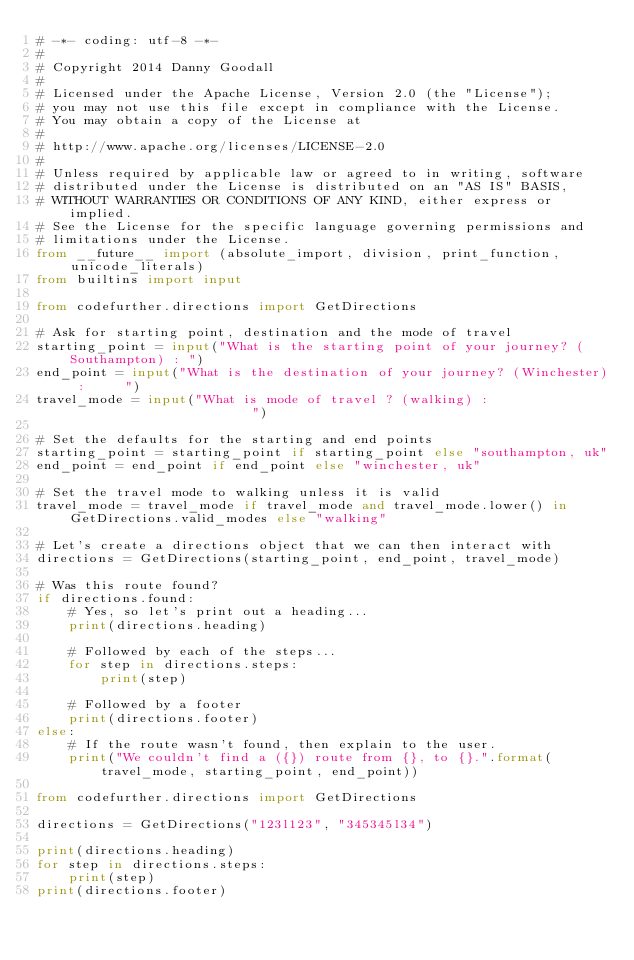Convert code to text. <code><loc_0><loc_0><loc_500><loc_500><_Python_># -*- coding: utf-8 -*-
#
# Copyright 2014 Danny Goodall
#
# Licensed under the Apache License, Version 2.0 (the "License");
# you may not use this file except in compliance with the License.
# You may obtain a copy of the License at
#
# http://www.apache.org/licenses/LICENSE-2.0
#
# Unless required by applicable law or agreed to in writing, software
# distributed under the License is distributed on an "AS IS" BASIS,
# WITHOUT WARRANTIES OR CONDITIONS OF ANY KIND, either express or implied.
# See the License for the specific language governing permissions and
# limitations under the License.
from __future__ import (absolute_import, division, print_function, unicode_literals)
from builtins import input

from codefurther.directions import GetDirections

# Ask for starting point, destination and the mode of travel
starting_point = input("What is the starting point of your journey? (Southampton) : ")
end_point = input("What is the destination of your journey? (Winchester) :     ")
travel_mode = input("What is mode of travel ? (walking) :                        ")

# Set the defaults for the starting and end points
starting_point = starting_point if starting_point else "southampton, uk"
end_point = end_point if end_point else "winchester, uk"

# Set the travel mode to walking unless it is valid
travel_mode = travel_mode if travel_mode and travel_mode.lower() in GetDirections.valid_modes else "walking"

# Let's create a directions object that we can then interact with
directions = GetDirections(starting_point, end_point, travel_mode)

# Was this route found?
if directions.found:
    # Yes, so let's print out a heading...
    print(directions.heading)

    # Followed by each of the steps...
    for step in directions.steps:
        print(step)

    # Followed by a footer
    print(directions.footer)
else:
    # If the route wasn't found, then explain to the user.
    print("We couldn't find a ({}) route from {}, to {}.".format(travel_mode, starting_point, end_point))

from codefurther.directions import GetDirections

directions = GetDirections("123l123", "345345l34")

print(directions.heading)
for step in directions.steps:
    print(step)
print(directions.footer)
</code> 